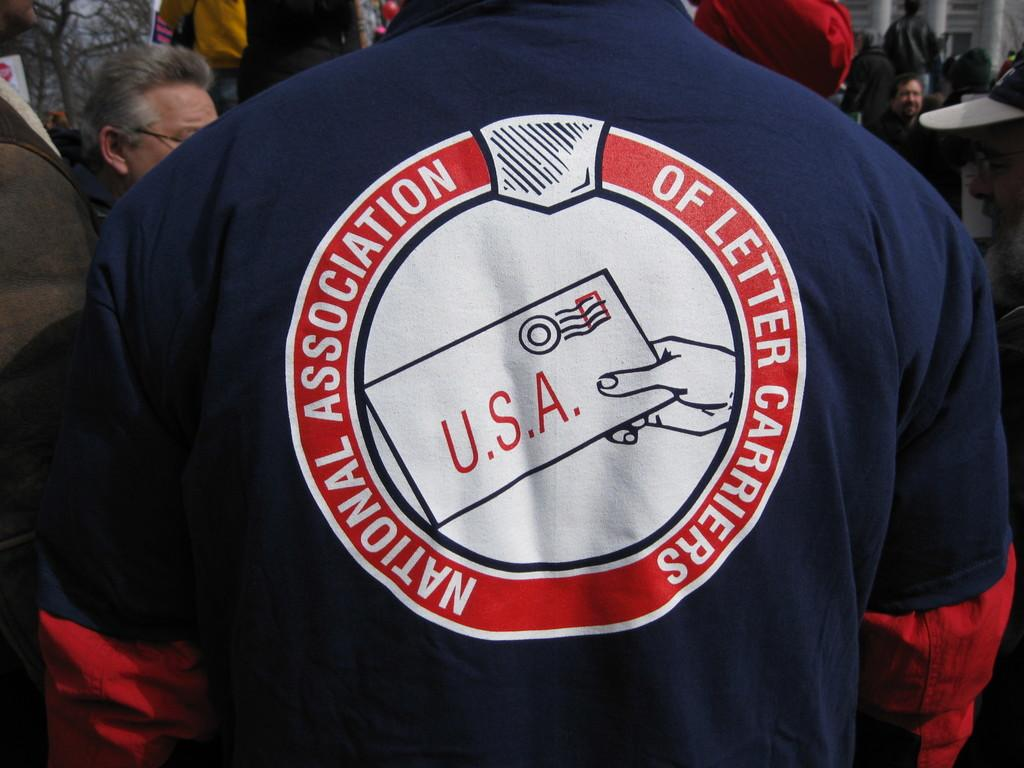<image>
Give a short and clear explanation of the subsequent image. The back of this person's shirt says "National Association of Letter Carriers" on it. 